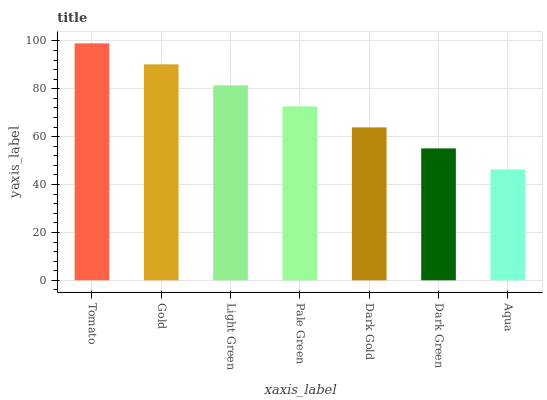Is Aqua the minimum?
Answer yes or no. Yes. Is Tomato the maximum?
Answer yes or no. Yes. Is Gold the minimum?
Answer yes or no. No. Is Gold the maximum?
Answer yes or no. No. Is Tomato greater than Gold?
Answer yes or no. Yes. Is Gold less than Tomato?
Answer yes or no. Yes. Is Gold greater than Tomato?
Answer yes or no. No. Is Tomato less than Gold?
Answer yes or no. No. Is Pale Green the high median?
Answer yes or no. Yes. Is Pale Green the low median?
Answer yes or no. Yes. Is Tomato the high median?
Answer yes or no. No. Is Gold the low median?
Answer yes or no. No. 